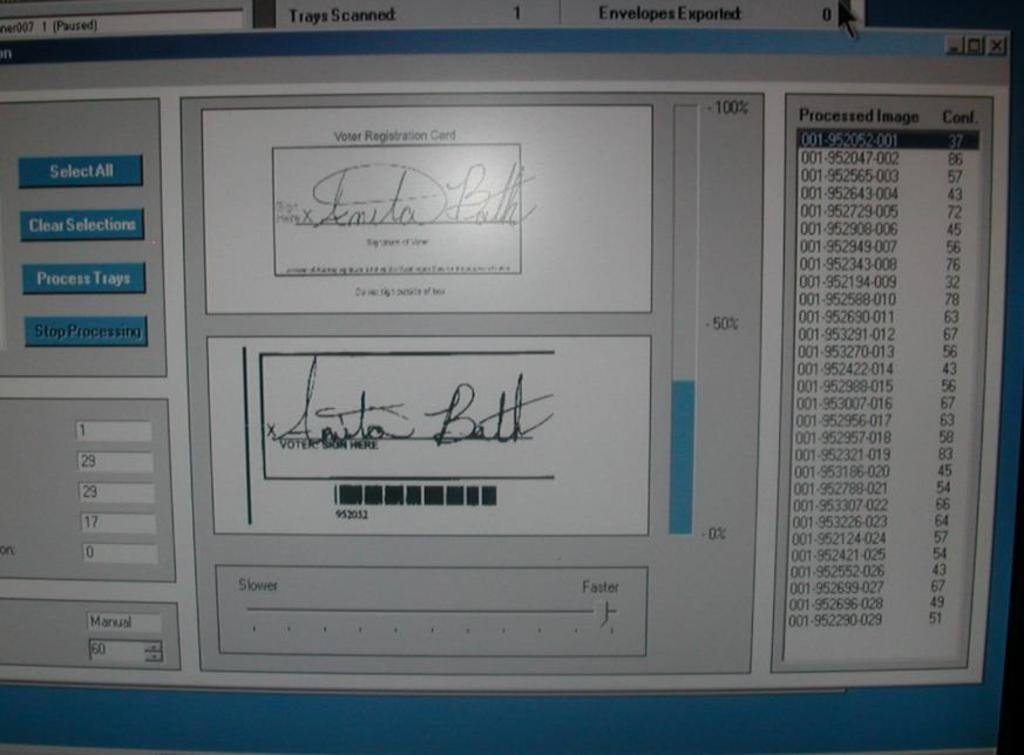<image>
Render a clear and concise summary of the photo. A computer monitor's shot of a voter registration card signed in cursive. 